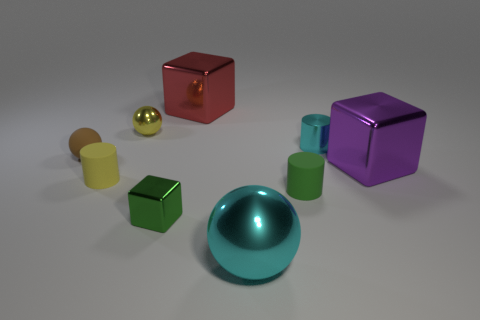There is a thing that is the same color as the tiny shiny cylinder; what is its size?
Provide a succinct answer. Large. What is the color of the other ball that is the same size as the yellow shiny ball?
Provide a succinct answer. Brown. What number of brown rubber things have the same shape as the big red object?
Your answer should be compact. 0. There is a tiny matte sphere that is left of the cyan cylinder; what color is it?
Make the answer very short. Brown. What number of matte objects are either yellow things or tiny blocks?
Provide a succinct answer. 1. There is a tiny thing that is the same color as the small metallic sphere; what shape is it?
Make the answer very short. Cylinder. What number of yellow cylinders have the same size as the yellow sphere?
Keep it short and to the point. 1. There is a cylinder that is to the right of the small shiny ball and in front of the metallic cylinder; what color is it?
Ensure brevity in your answer.  Green. What number of objects are large red metallic cubes or small yellow matte objects?
Provide a short and direct response. 2. How many big objects are cyan metal objects or brown objects?
Your response must be concise. 1. 